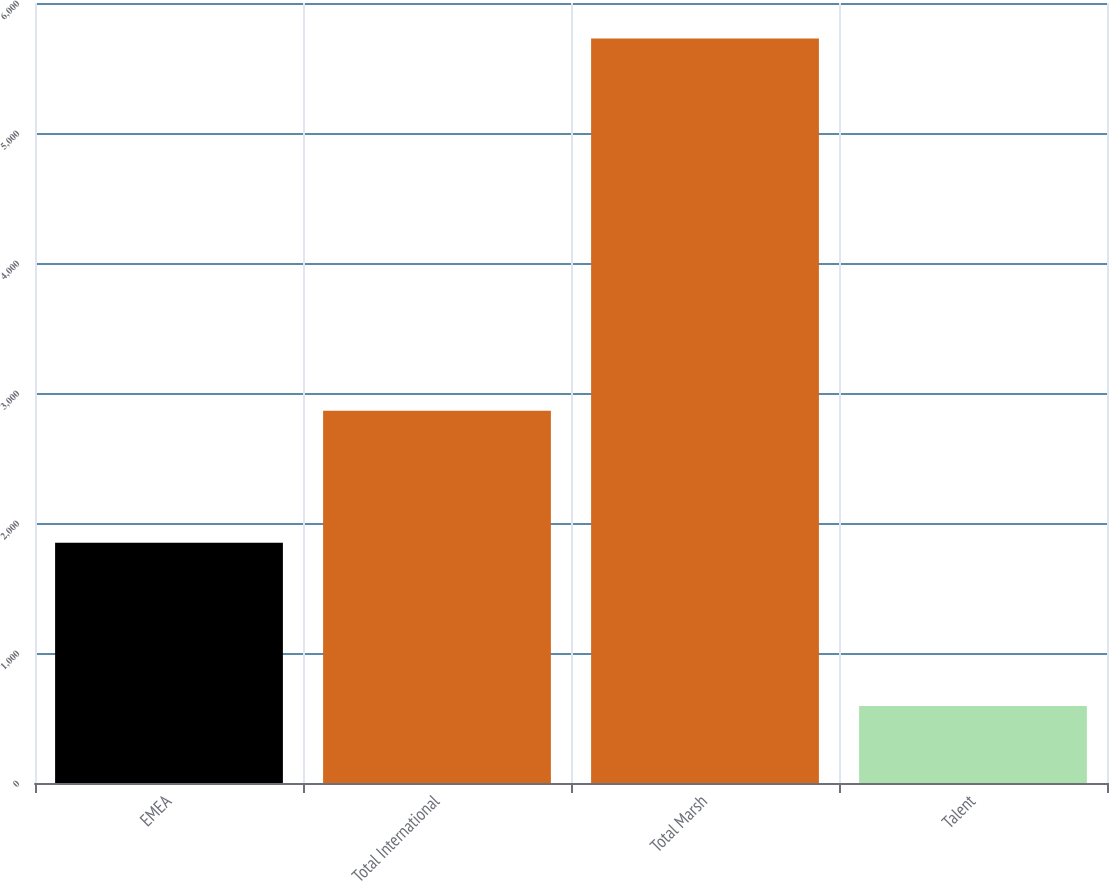<chart> <loc_0><loc_0><loc_500><loc_500><bar_chart><fcel>EMEA<fcel>Total International<fcel>Total Marsh<fcel>Talent<nl><fcel>1848<fcel>2864<fcel>5727<fcel>592<nl></chart> 